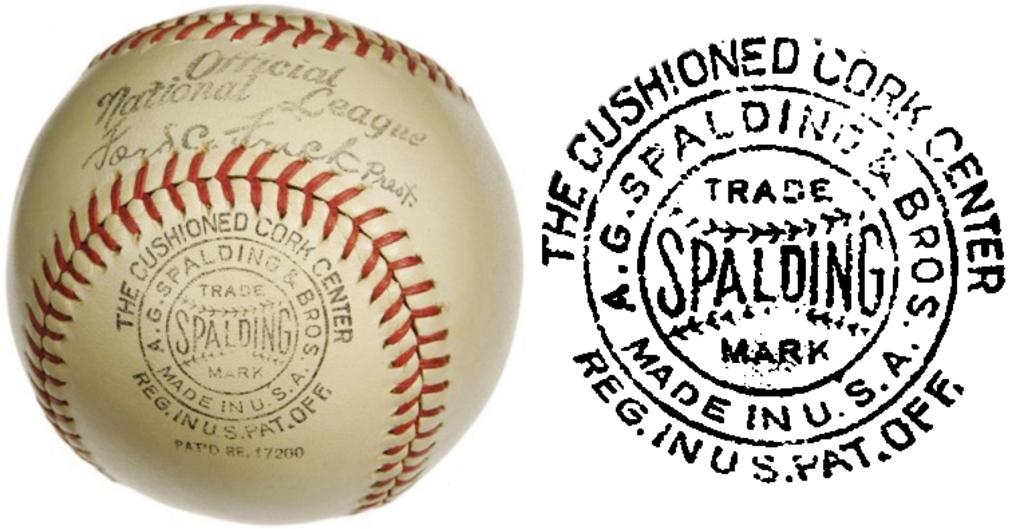Provide a one-sentence caption for the provided image. An Official National League baseball bearing the spalding logo next to the logo itself. 